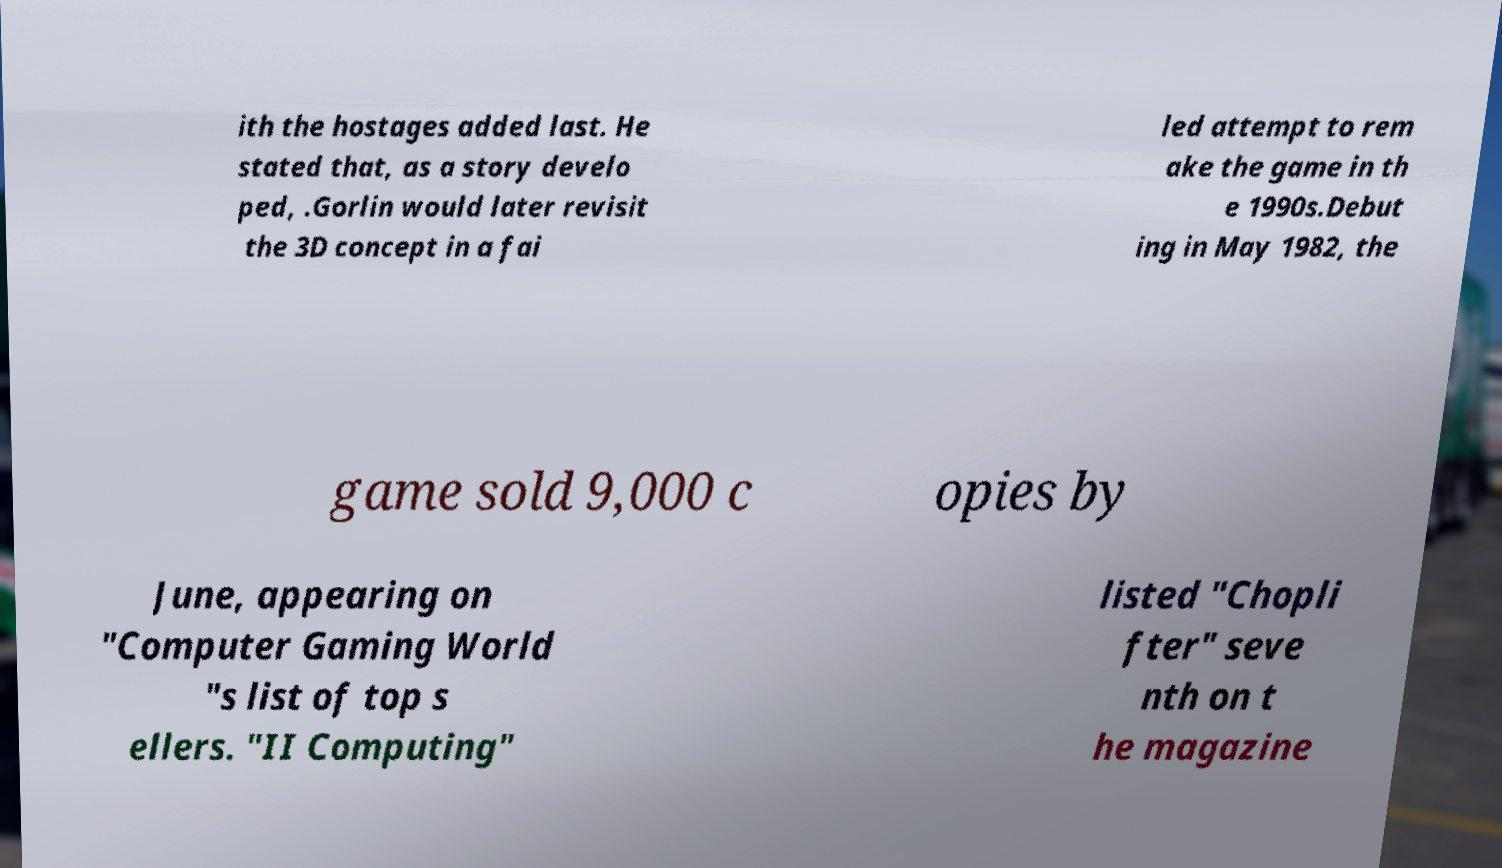What messages or text are displayed in this image? I need them in a readable, typed format. ith the hostages added last. He stated that, as a story develo ped, .Gorlin would later revisit the 3D concept in a fai led attempt to rem ake the game in th e 1990s.Debut ing in May 1982, the game sold 9,000 c opies by June, appearing on "Computer Gaming World "s list of top s ellers. "II Computing" listed "Chopli fter" seve nth on t he magazine 